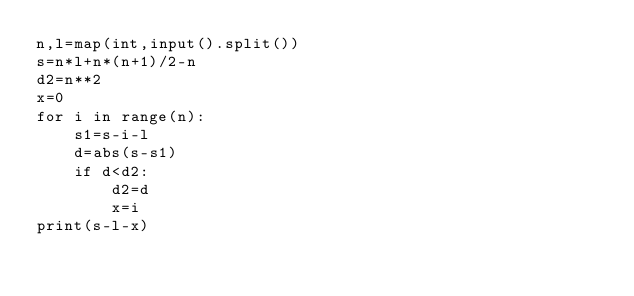Convert code to text. <code><loc_0><loc_0><loc_500><loc_500><_Python_>n,l=map(int,input().split())
s=n*l+n*(n+1)/2-n
d2=n**2
x=0
for i in range(n):
    s1=s-i-l
    d=abs(s-s1)
    if d<d2:
        d2=d
        x=i
print(s-l-x)</code> 